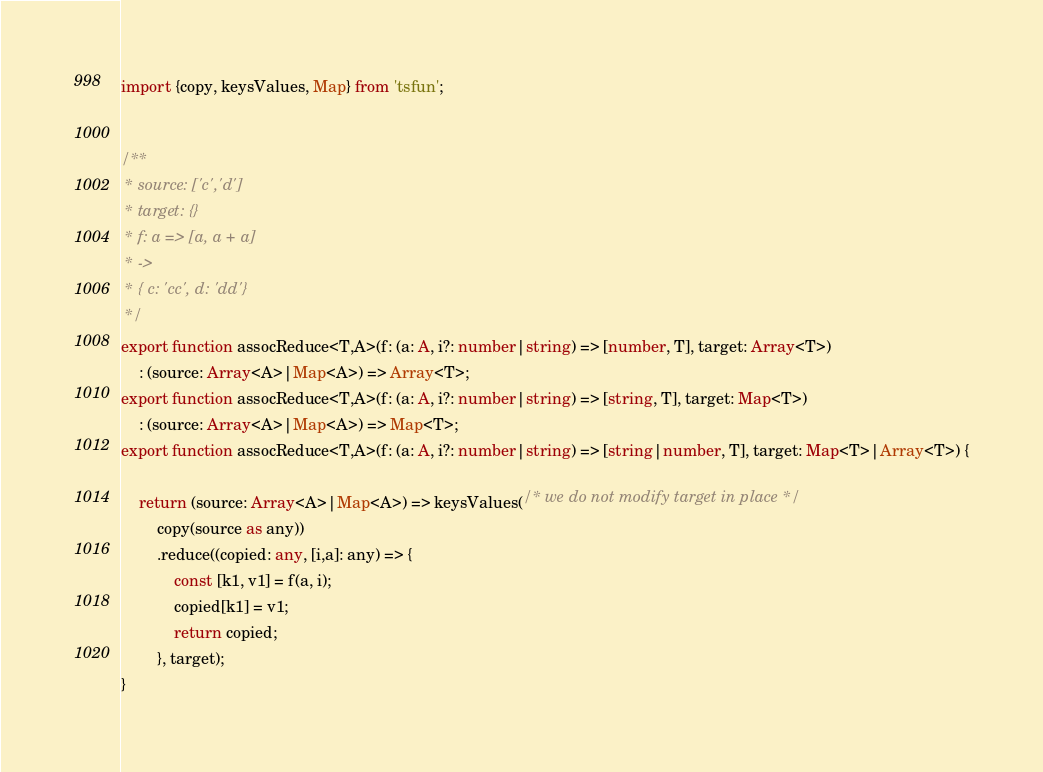Convert code to text. <code><loc_0><loc_0><loc_500><loc_500><_TypeScript_>import {copy, keysValues, Map} from 'tsfun';


/**
 * source: ['c','d']
 * target: {}
 * f: a => [a, a + a]
 * ->
 * { c: 'cc', d: 'dd'}
 */
export function assocReduce<T,A>(f: (a: A, i?: number|string) => [number, T], target: Array<T>)
    : (source: Array<A>|Map<A>) => Array<T>;
export function assocReduce<T,A>(f: (a: A, i?: number|string) => [string, T], target: Map<T>)
    : (source: Array<A>|Map<A>) => Map<T>;
export function assocReduce<T,A>(f: (a: A, i?: number|string) => [string|number, T], target: Map<T>|Array<T>) {

    return (source: Array<A>|Map<A>) => keysValues(/* we do not modify target in place */
        copy(source as any))
        .reduce((copied: any, [i,a]: any) => {
            const [k1, v1] = f(a, i);
            copied[k1] = v1;
            return copied;
        }, target);
}
</code> 